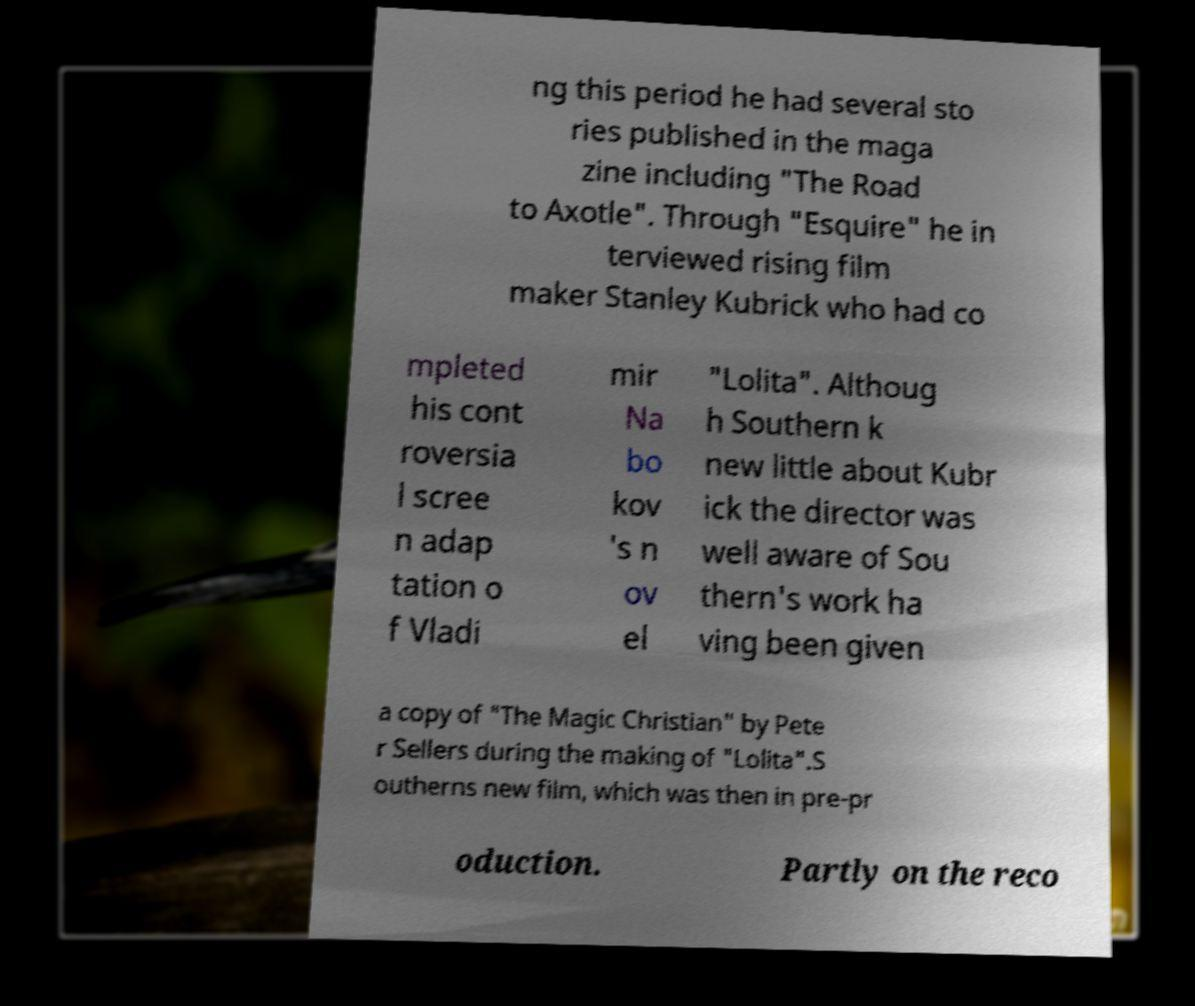Can you read and provide the text displayed in the image?This photo seems to have some interesting text. Can you extract and type it out for me? ng this period he had several sto ries published in the maga zine including "The Road to Axotle". Through "Esquire" he in terviewed rising film maker Stanley Kubrick who had co mpleted his cont roversia l scree n adap tation o f Vladi mir Na bo kov 's n ov el "Lolita". Althoug h Southern k new little about Kubr ick the director was well aware of Sou thern's work ha ving been given a copy of "The Magic Christian" by Pete r Sellers during the making of "Lolita".S outherns new film, which was then in pre-pr oduction. Partly on the reco 